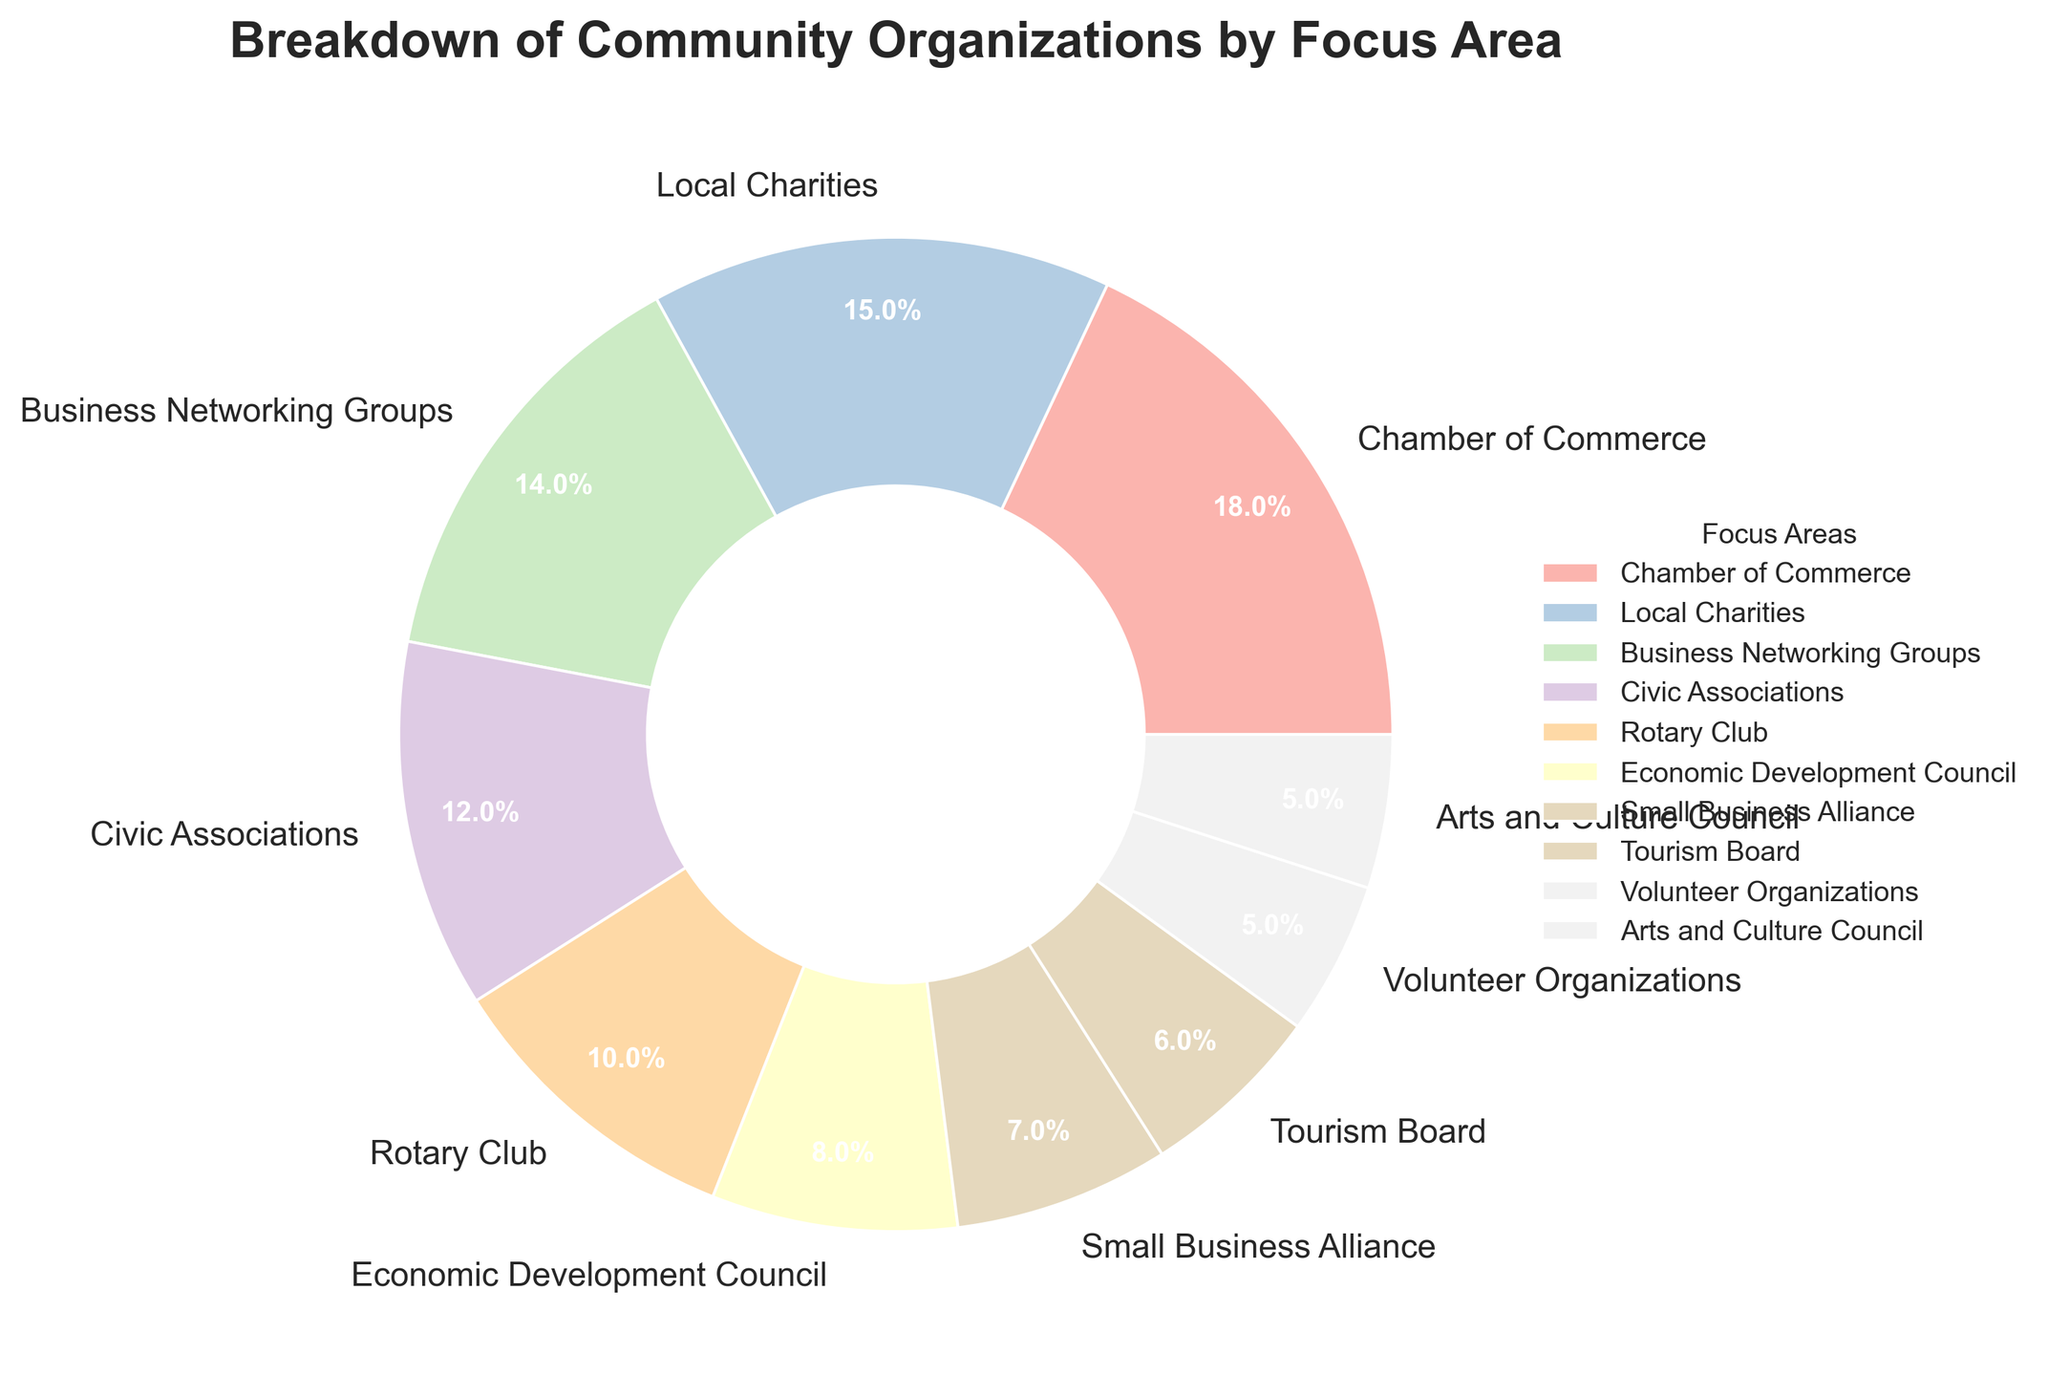What is the percentage of the largest focus area? The largest focus area can be identified as the one with the highest percentage. According to the pie chart, the Chamber of Commerce has the highest percentage at 18%.
Answer: 18% Which focus areas have the same percentage? By examining the percentages, we see that Arts and Culture Council and Volunteer Organizations each account for 5%.
Answer: Arts and Culture Council and Volunteer Organizations What is the combined percentage of the top three focus areas? The top three focus areas are the Chamber of Commerce, Local Charities, and Business Networking Groups. Their combined percentage is 18% + 15% + 14% = 47%.
Answer: 47% How much greater is the percentage of the Chamber of Commerce compared to the Small Business Alliance? The percentage of the Chamber of Commerce is 18%, and the Small Business Alliance is 7%. The difference is 18% - 7% = 11%.
Answer: 11% Is the Rotary Club's percentage greater than the Arts and Culture Council's percentage? The Rotary Club has a percentage of 10%, while the Arts and Culture Council has a percentage of 5%. Since 10% is greater than 5%, the Rotary Club's percentage is indeed greater.
Answer: Yes What is the combined percentage of Rotary Club, Economic Development Council, and Small Business Alliance? Summing the percentages of Rotary Club (10%), Economic Development Council (8%), and Small Business Alliance (7%) gives 10% + 8% + 7% = 25%.
Answer: 25% How much less is the percentage of the Tourism Board compared to the Business Networking Groups? The percentage of the Tourism Board is 6%, and the Business Networking Groups is 14%. The difference is 14% - 6% = 8%.
Answer: 8% What is the average percentage of the Local Charities, Civic Associations, and Tourism Board? The percentages are 15%, 12%, and 6%. Adding these gives 15% + 12% + 6% = 33%, and the average is 33% / 3 = 11%.
Answer: 11% Which focus area has the smallest percentage? The pie chart shows that Volunteer Organizations and Arts and Culture Council both have the smallest percentage, each at 5%.
Answer: Volunteer Organizations and Arts and Culture Council What are the percentages of focus areas with less than 10%? Scanning the chart for percentages less than 10%, we find Economic Development Council (8%), Small Business Alliance (7%), Tourism Board (6%), Volunteer Organizations (5%), and Arts and Culture Council (5%).
Answer: Economic Development Council, Small Business Alliance, Tourism Board, Volunteer Organizations, Arts and Culture Council 